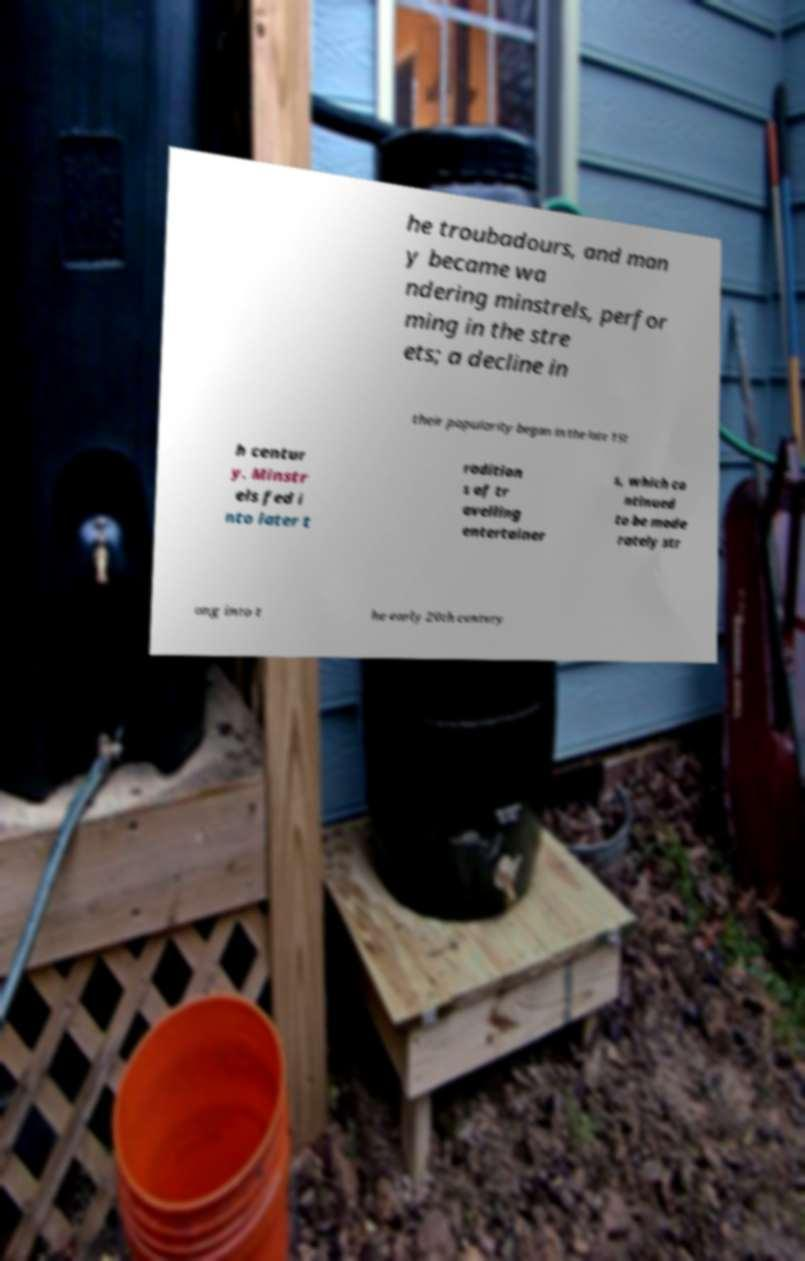For documentation purposes, I need the text within this image transcribed. Could you provide that? he troubadours, and man y became wa ndering minstrels, perfor ming in the stre ets; a decline in their popularity began in the late 15t h centur y. Minstr els fed i nto later t radition s of tr avelling entertainer s, which co ntinued to be mode rately str ong into t he early 20th century 